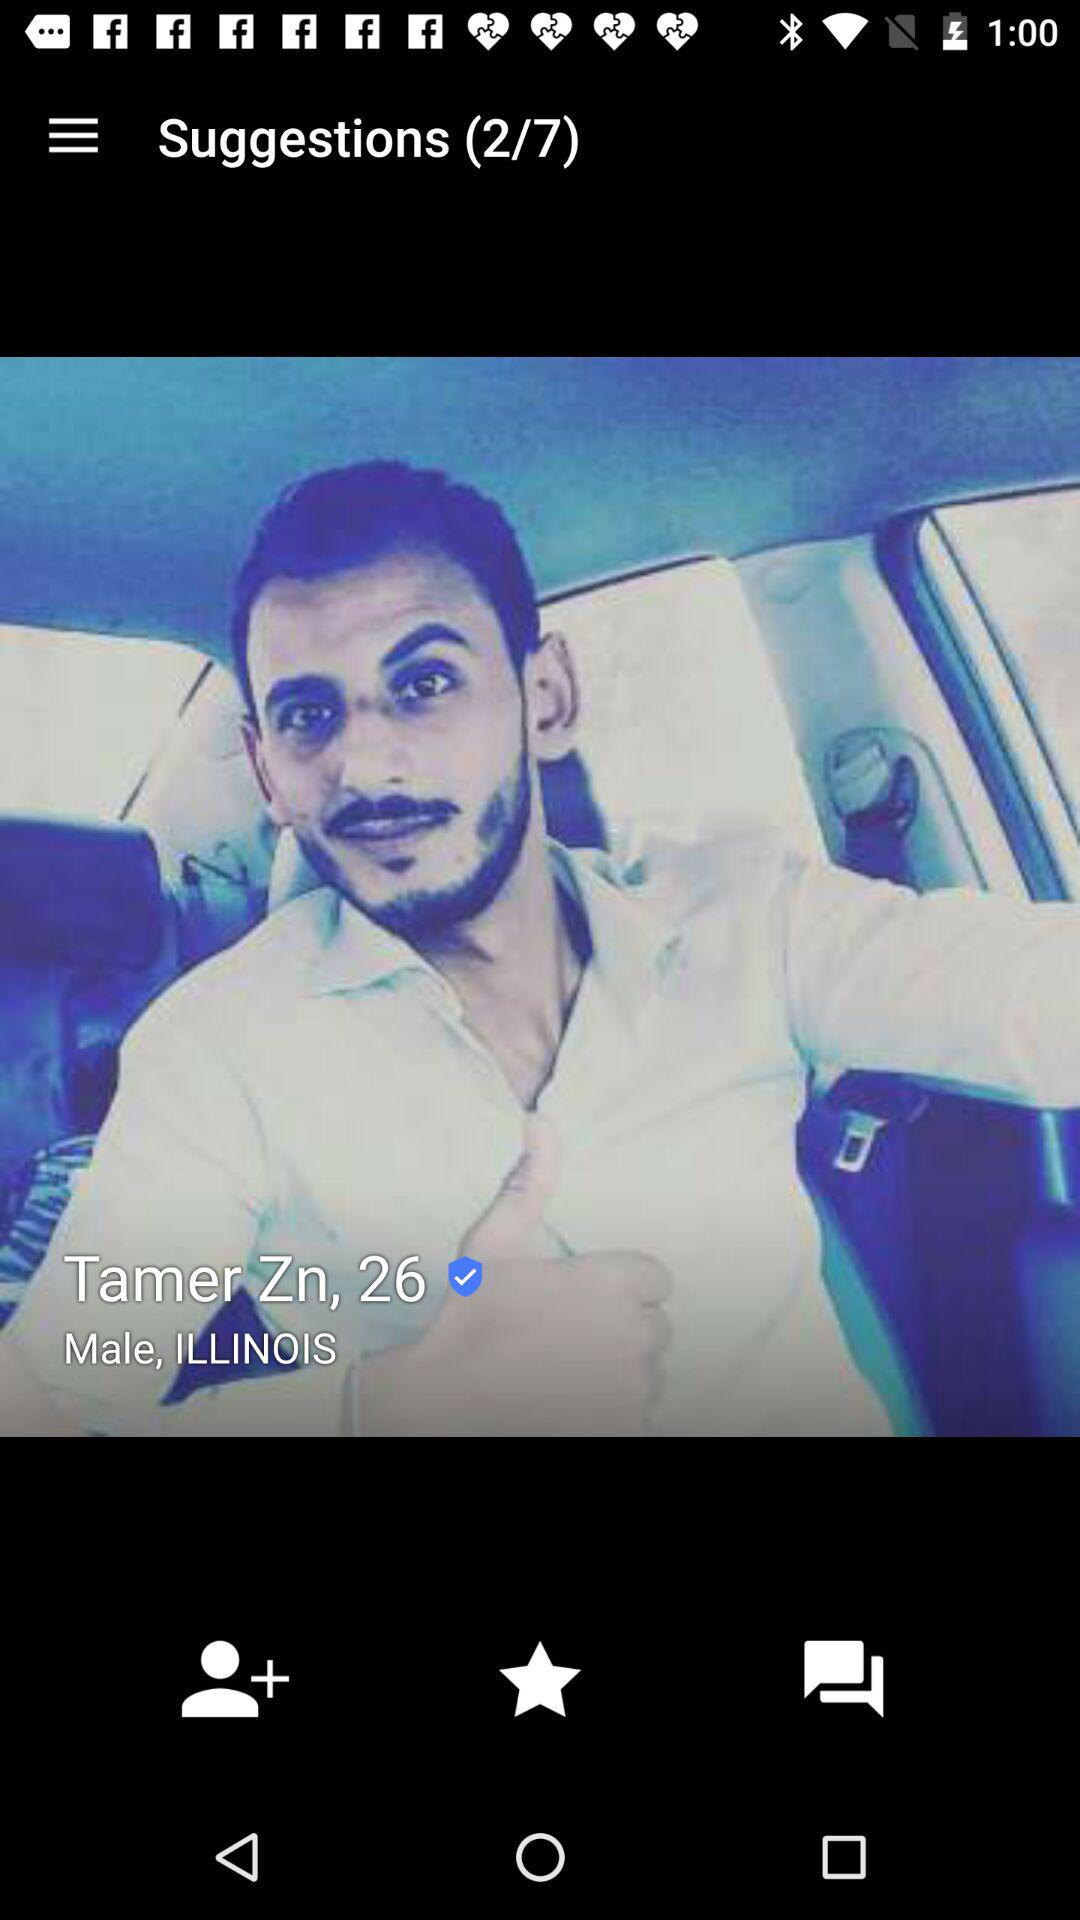What suggestion number am I on? The suggestion number you are on is 2. 